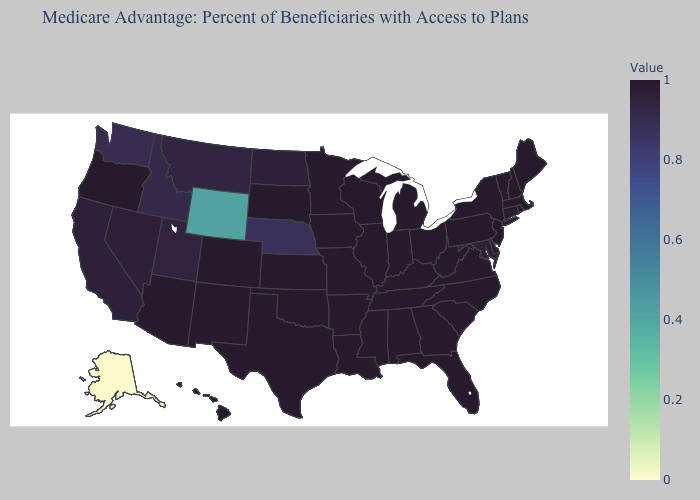Does West Virginia have the lowest value in the South?
Short answer required. No. Among the states that border Montana , does South Dakota have the highest value?
Give a very brief answer. Yes. Among the states that border Utah , does Arizona have the highest value?
Answer briefly. Yes. Is the legend a continuous bar?
Keep it brief. Yes. Which states have the lowest value in the USA?
Keep it brief. Alaska. Which states hav the highest value in the West?
Quick response, please. Hawaii, New Mexico, Oregon, Arizona. Among the states that border Missouri , does Nebraska have the highest value?
Concise answer only. No. 